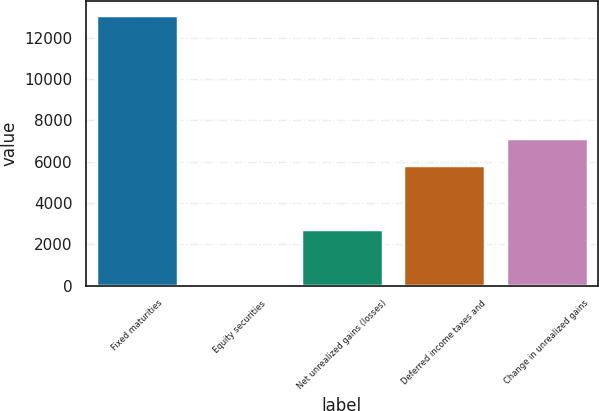Convert chart to OTSL. <chart><loc_0><loc_0><loc_500><loc_500><bar_chart><fcel>Fixed maturities<fcel>Equity securities<fcel>Net unrealized gains (losses)<fcel>Deferred income taxes and<fcel>Change in unrealized gains<nl><fcel>13126<fcel>96<fcel>2741.4<fcel>5837<fcel>7159.7<nl></chart> 